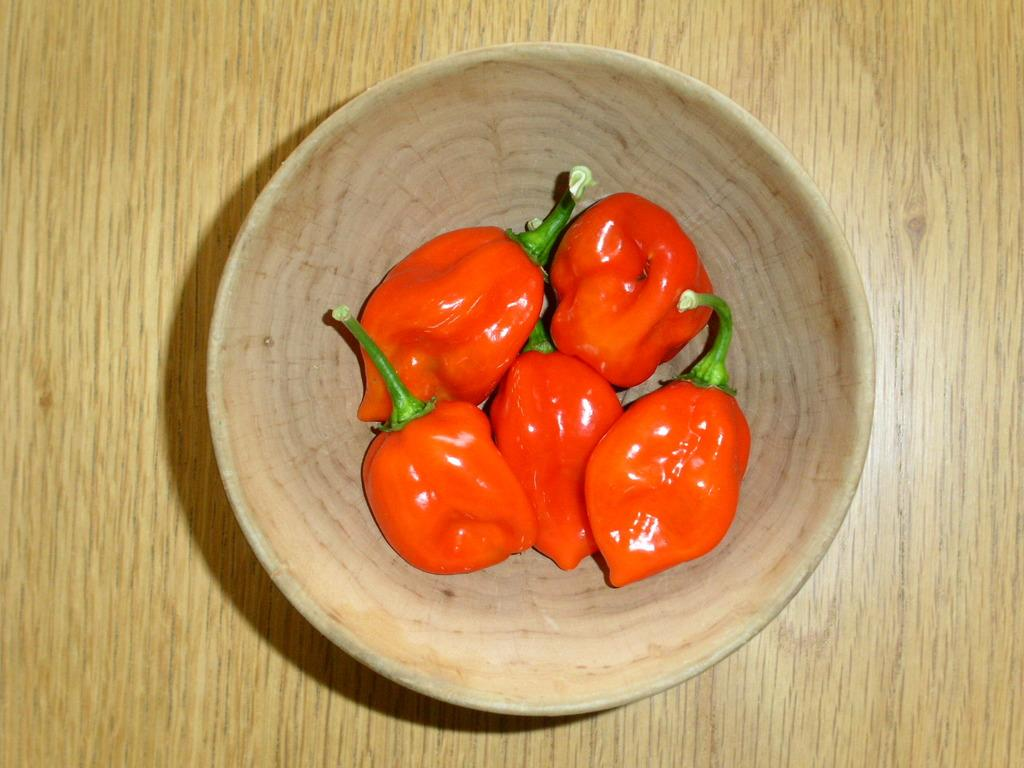What type of food item is present in the image? There are red chilies in the image. How are the red chilies arranged in the image? The red chilies are in a bowl. What is the bowl resting on in the image? The bowl is on a wooden surface. What type of mint can be seen growing near the bowl of red chilies in the image? There is no mint present in the image; it only features red chilies in a bowl on a wooden surface. 